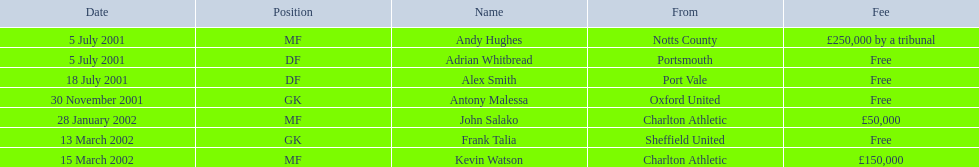Who are all the players? Andy Hughes, Adrian Whitbread, Alex Smith, Antony Malessa, John Salako, Frank Talia, Kevin Watson. What were their fees? £250,000 by a tribunal, Free, Free, Free, £50,000, Free, £150,000. And how much was kevin watson's fee? £150,000. Could you parse the entire table as a dict? {'header': ['Date', 'Position', 'Name', 'From', 'Fee'], 'rows': [['5 July 2001', 'MF', 'Andy Hughes', 'Notts County', '£250,000 by a tribunal'], ['5 July 2001', 'DF', 'Adrian Whitbread', 'Portsmouth', 'Free'], ['18 July 2001', 'DF', 'Alex Smith', 'Port Vale', 'Free'], ['30 November 2001', 'GK', 'Antony Malessa', 'Oxford United', 'Free'], ['28 January 2002', 'MF', 'John Salako', 'Charlton Athletic', '£50,000'], ['13 March 2002', 'GK', 'Frank Talia', 'Sheffield United', 'Free'], ['15 March 2002', 'MF', 'Kevin Watson', 'Charlton Athletic', '£150,000']]} 